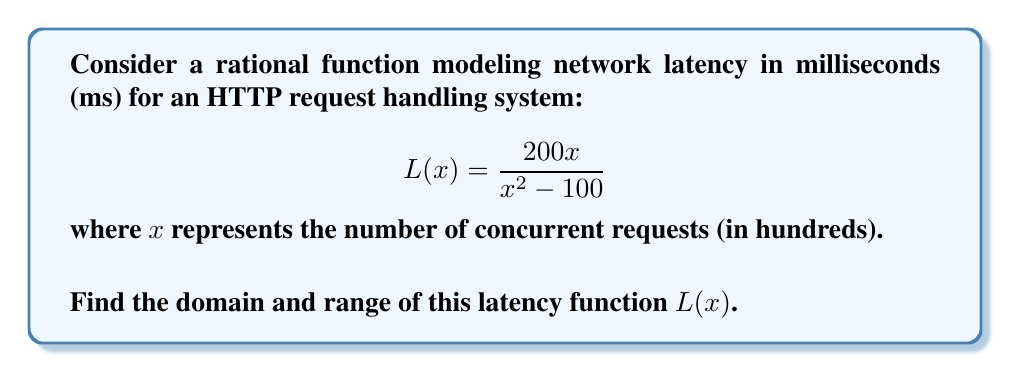Help me with this question. To find the domain and range of the rational function $L(x) = \frac{200x}{x^2 - 100}$, we'll follow these steps:

1. Domain:
   The domain consists of all real numbers except those that make the denominator zero.
   Set the denominator to zero and solve:
   $x^2 - 100 = 0$
   $(x+10)(x-10) = 0$
   $x = \pm 10$

   Therefore, the domain is all real numbers except $\pm 10$, or $x \in (-\infty, -10) \cup (-10, 10) \cup (10, \infty)$.

2. Range:
   To find the range, we'll analyze the behavior of the function:

   a) As $x \to \pm\infty$, $L(x) \to 0$ (horizontal asymptote).
   
   b) Find vertical asymptotes:
      When $x = \pm 10$, $L(x)$ is undefined (vertical asymptotes).

   c) Find $x$-intercept:
      When $y = 0$, $\frac{200x}{x^2 - 100} = 0$
      $200x = 0$, so $x = 0$
      $L(0) = 0$

   d) Find critical points:
      $L'(x) = \frac{200(x^2-100) - 200x(2x)}{(x^2-100)^2} = \frac{-200(x^2+100)}{(x^2-100)^2}$
      $L'(x) = 0$ when $x^2 + 100 = 0$, which has no real solutions.

   e) Analyze behavior near asymptotes:
      As $x \to 10^-$, $L(x) \to -\infty$
      As $x \to 10^+$, $L(x) \to +\infty$
      As $x \to -10^-$, $L(x) \to +\infty$
      As $x \to -10^+$, $L(x) \to -\infty$

   Based on this analysis, the function takes on all real values except 0.
   The range is $(-\infty, 0) \cup (0, \infty)$ or $\mathbb{R} \setminus \{0\}$.
Answer: Domain: $x \in (-\infty, -10) \cup (-10, 10) \cup (10, \infty)$
Range: $y \in (-\infty, 0) \cup (0, \infty)$ 